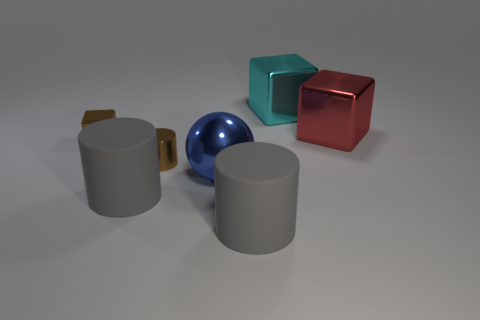Can you describe the lighting and shading in the scene? The lighting in this scene seems to mimic an overhead source, creating soft shadows that fall mostly to the right of the objects. The highlights and reflections on the surfaces, especially noticeable on the blue sphere, suggest the material is somewhat glossy. 